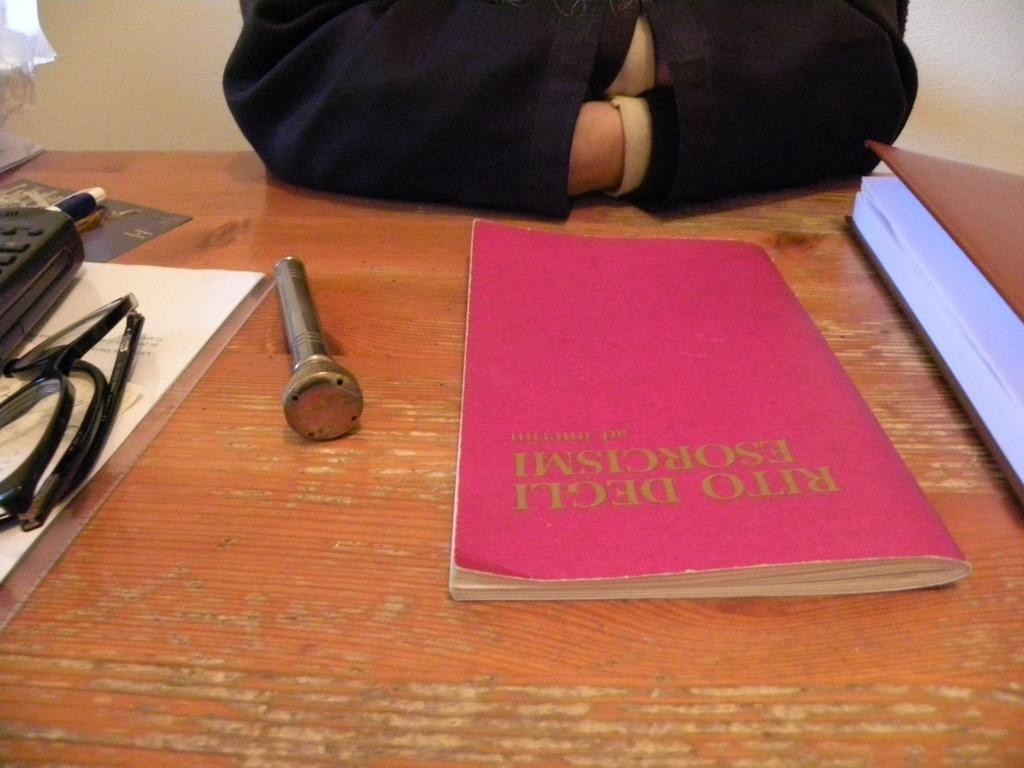<image>
Write a terse but informative summary of the picture. A man sits in front of a book titled Rito Degli: Esorcismi. 